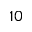Convert formula to latex. <formula><loc_0><loc_0><loc_500><loc_500>1 0</formula> 